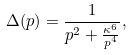<formula> <loc_0><loc_0><loc_500><loc_500>\Delta ( p ) = \frac { 1 } { p ^ { 2 } + \frac { \kappa ^ { 6 } } { p ^ { 4 } } } ,</formula> 